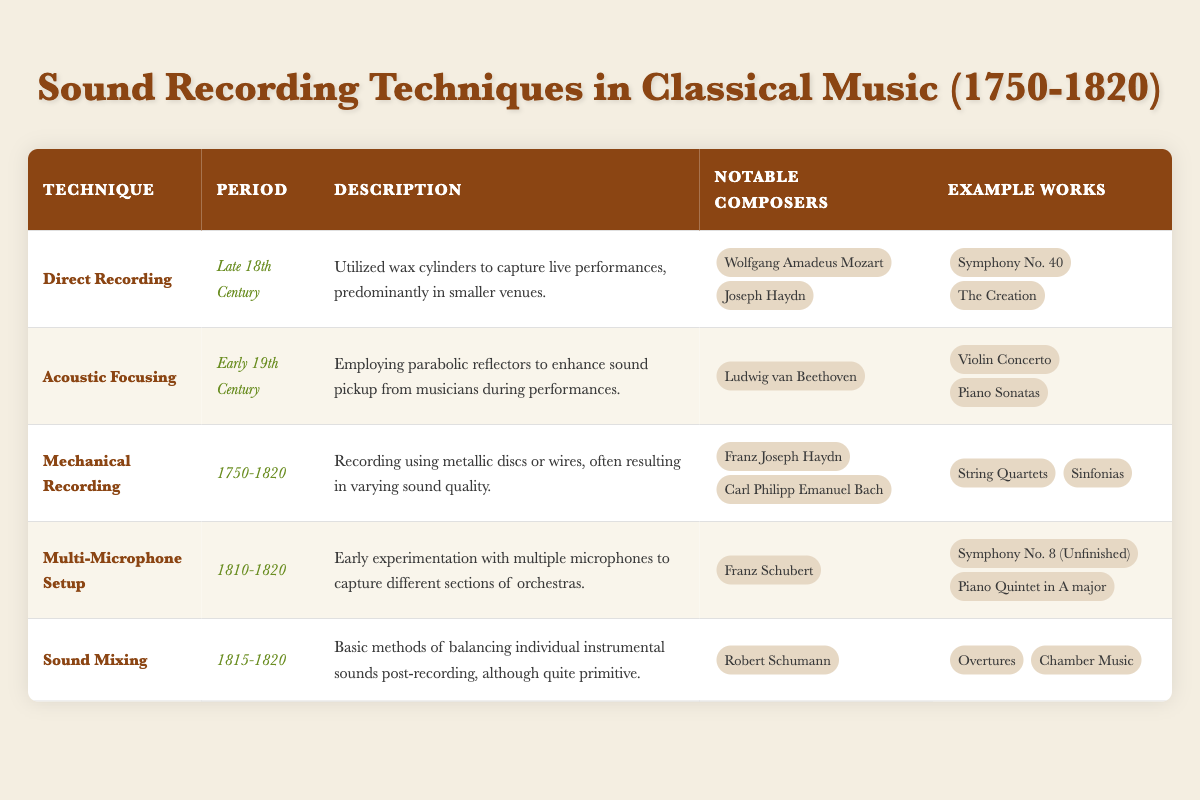What technique was used in the late 18th century for recording? According to the table, the technique used in the late 18th century for recording is "Direct Recording."
Answer: Direct Recording Which composers are associated with the technique of Acoustic Focusing? The table specifies that the notable composer associated with Acoustic Focusing is Ludwig van Beethoven.
Answer: Ludwig van Beethoven True or False: The technique of Sound Mixing was available during the 1750-1820 period. The table states that Sound Mixing was used from 1815 to 1820; therefore, it was not available during the full 1750-1820 period.
Answer: False What is the description of Mechanical Recording? The table describes Mechanical Recording as using metallic discs or wires, often resulting in varying sound quality.
Answer: Recording using metallic discs or wires, often resulting in varying sound quality Which composers created works during the period of 1810-1820? Looking through the table, the composers noted during 1810-1820 include Franz Schubert and Robert Schumann.
Answer: Franz Schubert, Robert Schumann What is the total number of notable composers mentioned across all techniques? By counting the individual notable composers (Mozart, Haydn, Beethoven, Schubert, and Schumann), the total comes to five unique composers. However, Carl Philipp Emanuel Bach is also included. Hence, the total number of unique composers is 6.
Answer: 6 What type of recording technique uses multiple microphones? The table indicates that the "Multi-Microphone Setup" is the technique that involves using multiple microphones to capture different sections of orchestras.
Answer: Multi-Microphone Setup Which technique mentioned had its peak in the early 19th century? According to the table, "Acoustic Focusing" peaked in the early 19th century.
Answer: Acoustic Focusing What are the example works associated with Franz Joseph Haydn under Mechanical Recording? The table lists "String Quartets" and "Sinfonias" as the example works associated with Franz Joseph Haydn under Mechanical Recording.
Answer: String Quartets, Sinfonias 